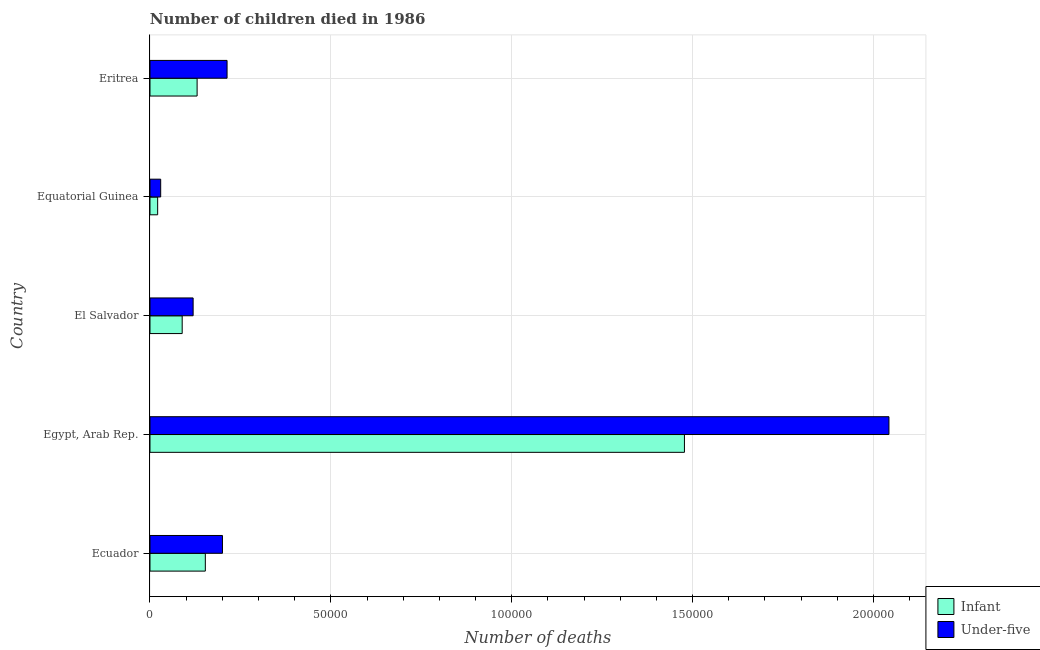Are the number of bars per tick equal to the number of legend labels?
Provide a succinct answer. Yes. Are the number of bars on each tick of the Y-axis equal?
Your answer should be very brief. Yes. How many bars are there on the 2nd tick from the top?
Give a very brief answer. 2. What is the label of the 3rd group of bars from the top?
Give a very brief answer. El Salvador. In how many cases, is the number of bars for a given country not equal to the number of legend labels?
Keep it short and to the point. 0. What is the number of under-five deaths in Ecuador?
Your answer should be very brief. 2.00e+04. Across all countries, what is the maximum number of infant deaths?
Offer a terse response. 1.48e+05. Across all countries, what is the minimum number of infant deaths?
Make the answer very short. 2121. In which country was the number of infant deaths maximum?
Offer a very short reply. Egypt, Arab Rep. In which country was the number of infant deaths minimum?
Your answer should be very brief. Equatorial Guinea. What is the total number of under-five deaths in the graph?
Ensure brevity in your answer.  2.61e+05. What is the difference between the number of infant deaths in El Salvador and that in Eritrea?
Ensure brevity in your answer.  -4123. What is the difference between the number of under-five deaths in Eritrea and the number of infant deaths in Equatorial Guinea?
Offer a very short reply. 1.92e+04. What is the average number of infant deaths per country?
Provide a succinct answer. 3.74e+04. What is the difference between the number of infant deaths and number of under-five deaths in Ecuador?
Ensure brevity in your answer.  -4734. In how many countries, is the number of infant deaths greater than 40000 ?
Offer a terse response. 1. What is the ratio of the number of infant deaths in Egypt, Arab Rep. to that in Equatorial Guinea?
Give a very brief answer. 69.66. What is the difference between the highest and the second highest number of under-five deaths?
Provide a short and direct response. 1.83e+05. What is the difference between the highest and the lowest number of under-five deaths?
Ensure brevity in your answer.  2.01e+05. Is the sum of the number of infant deaths in Equatorial Guinea and Eritrea greater than the maximum number of under-five deaths across all countries?
Give a very brief answer. No. What does the 2nd bar from the top in Ecuador represents?
Offer a very short reply. Infant. What does the 2nd bar from the bottom in Equatorial Guinea represents?
Offer a very short reply. Under-five. How many bars are there?
Give a very brief answer. 10. Are all the bars in the graph horizontal?
Keep it short and to the point. Yes. How many countries are there in the graph?
Your answer should be very brief. 5. What is the difference between two consecutive major ticks on the X-axis?
Make the answer very short. 5.00e+04. Are the values on the major ticks of X-axis written in scientific E-notation?
Ensure brevity in your answer.  No. How many legend labels are there?
Offer a terse response. 2. What is the title of the graph?
Keep it short and to the point. Number of children died in 1986. Does "Fertility rate" appear as one of the legend labels in the graph?
Ensure brevity in your answer.  No. What is the label or title of the X-axis?
Offer a very short reply. Number of deaths. What is the Number of deaths of Infant in Ecuador?
Offer a terse response. 1.53e+04. What is the Number of deaths of Under-five in Ecuador?
Your answer should be compact. 2.00e+04. What is the Number of deaths in Infant in Egypt, Arab Rep.?
Your answer should be compact. 1.48e+05. What is the Number of deaths in Under-five in Egypt, Arab Rep.?
Offer a very short reply. 2.04e+05. What is the Number of deaths in Infant in El Salvador?
Your answer should be compact. 8903. What is the Number of deaths in Under-five in El Salvador?
Keep it short and to the point. 1.19e+04. What is the Number of deaths of Infant in Equatorial Guinea?
Provide a succinct answer. 2121. What is the Number of deaths of Under-five in Equatorial Guinea?
Provide a succinct answer. 2956. What is the Number of deaths in Infant in Eritrea?
Offer a very short reply. 1.30e+04. What is the Number of deaths in Under-five in Eritrea?
Your answer should be very brief. 2.13e+04. Across all countries, what is the maximum Number of deaths in Infant?
Keep it short and to the point. 1.48e+05. Across all countries, what is the maximum Number of deaths in Under-five?
Keep it short and to the point. 2.04e+05. Across all countries, what is the minimum Number of deaths of Infant?
Your response must be concise. 2121. Across all countries, what is the minimum Number of deaths in Under-five?
Your answer should be compact. 2956. What is the total Number of deaths of Infant in the graph?
Make the answer very short. 1.87e+05. What is the total Number of deaths in Under-five in the graph?
Your answer should be compact. 2.61e+05. What is the difference between the Number of deaths in Infant in Ecuador and that in Egypt, Arab Rep.?
Your answer should be very brief. -1.32e+05. What is the difference between the Number of deaths of Under-five in Ecuador and that in Egypt, Arab Rep.?
Offer a very short reply. -1.84e+05. What is the difference between the Number of deaths in Infant in Ecuador and that in El Salvador?
Give a very brief answer. 6395. What is the difference between the Number of deaths in Under-five in Ecuador and that in El Salvador?
Your answer should be compact. 8105. What is the difference between the Number of deaths in Infant in Ecuador and that in Equatorial Guinea?
Your answer should be compact. 1.32e+04. What is the difference between the Number of deaths in Under-five in Ecuador and that in Equatorial Guinea?
Give a very brief answer. 1.71e+04. What is the difference between the Number of deaths of Infant in Ecuador and that in Eritrea?
Provide a short and direct response. 2272. What is the difference between the Number of deaths of Under-five in Ecuador and that in Eritrea?
Offer a very short reply. -1276. What is the difference between the Number of deaths of Infant in Egypt, Arab Rep. and that in El Salvador?
Your response must be concise. 1.39e+05. What is the difference between the Number of deaths of Under-five in Egypt, Arab Rep. and that in El Salvador?
Your answer should be compact. 1.92e+05. What is the difference between the Number of deaths in Infant in Egypt, Arab Rep. and that in Equatorial Guinea?
Make the answer very short. 1.46e+05. What is the difference between the Number of deaths in Under-five in Egypt, Arab Rep. and that in Equatorial Guinea?
Your response must be concise. 2.01e+05. What is the difference between the Number of deaths in Infant in Egypt, Arab Rep. and that in Eritrea?
Your answer should be very brief. 1.35e+05. What is the difference between the Number of deaths of Under-five in Egypt, Arab Rep. and that in Eritrea?
Offer a very short reply. 1.83e+05. What is the difference between the Number of deaths of Infant in El Salvador and that in Equatorial Guinea?
Your answer should be compact. 6782. What is the difference between the Number of deaths of Under-five in El Salvador and that in Equatorial Guinea?
Keep it short and to the point. 8971. What is the difference between the Number of deaths of Infant in El Salvador and that in Eritrea?
Offer a very short reply. -4123. What is the difference between the Number of deaths in Under-five in El Salvador and that in Eritrea?
Offer a terse response. -9381. What is the difference between the Number of deaths in Infant in Equatorial Guinea and that in Eritrea?
Provide a succinct answer. -1.09e+04. What is the difference between the Number of deaths in Under-five in Equatorial Guinea and that in Eritrea?
Ensure brevity in your answer.  -1.84e+04. What is the difference between the Number of deaths of Infant in Ecuador and the Number of deaths of Under-five in Egypt, Arab Rep.?
Your response must be concise. -1.89e+05. What is the difference between the Number of deaths of Infant in Ecuador and the Number of deaths of Under-five in El Salvador?
Your answer should be compact. 3371. What is the difference between the Number of deaths in Infant in Ecuador and the Number of deaths in Under-five in Equatorial Guinea?
Your response must be concise. 1.23e+04. What is the difference between the Number of deaths in Infant in Ecuador and the Number of deaths in Under-five in Eritrea?
Offer a terse response. -6010. What is the difference between the Number of deaths in Infant in Egypt, Arab Rep. and the Number of deaths in Under-five in El Salvador?
Provide a short and direct response. 1.36e+05. What is the difference between the Number of deaths in Infant in Egypt, Arab Rep. and the Number of deaths in Under-five in Equatorial Guinea?
Make the answer very short. 1.45e+05. What is the difference between the Number of deaths in Infant in Egypt, Arab Rep. and the Number of deaths in Under-five in Eritrea?
Provide a succinct answer. 1.26e+05. What is the difference between the Number of deaths in Infant in El Salvador and the Number of deaths in Under-five in Equatorial Guinea?
Give a very brief answer. 5947. What is the difference between the Number of deaths in Infant in El Salvador and the Number of deaths in Under-five in Eritrea?
Your answer should be very brief. -1.24e+04. What is the difference between the Number of deaths of Infant in Equatorial Guinea and the Number of deaths of Under-five in Eritrea?
Offer a terse response. -1.92e+04. What is the average Number of deaths in Infant per country?
Your response must be concise. 3.74e+04. What is the average Number of deaths in Under-five per country?
Ensure brevity in your answer.  5.21e+04. What is the difference between the Number of deaths in Infant and Number of deaths in Under-five in Ecuador?
Offer a terse response. -4734. What is the difference between the Number of deaths of Infant and Number of deaths of Under-five in Egypt, Arab Rep.?
Ensure brevity in your answer.  -5.65e+04. What is the difference between the Number of deaths of Infant and Number of deaths of Under-five in El Salvador?
Your answer should be very brief. -3024. What is the difference between the Number of deaths of Infant and Number of deaths of Under-five in Equatorial Guinea?
Your answer should be very brief. -835. What is the difference between the Number of deaths in Infant and Number of deaths in Under-five in Eritrea?
Ensure brevity in your answer.  -8282. What is the ratio of the Number of deaths of Infant in Ecuador to that in Egypt, Arab Rep.?
Keep it short and to the point. 0.1. What is the ratio of the Number of deaths in Under-five in Ecuador to that in Egypt, Arab Rep.?
Give a very brief answer. 0.1. What is the ratio of the Number of deaths in Infant in Ecuador to that in El Salvador?
Make the answer very short. 1.72. What is the ratio of the Number of deaths of Under-five in Ecuador to that in El Salvador?
Make the answer very short. 1.68. What is the ratio of the Number of deaths in Infant in Ecuador to that in Equatorial Guinea?
Your answer should be very brief. 7.21. What is the ratio of the Number of deaths of Under-five in Ecuador to that in Equatorial Guinea?
Give a very brief answer. 6.78. What is the ratio of the Number of deaths of Infant in Ecuador to that in Eritrea?
Your response must be concise. 1.17. What is the ratio of the Number of deaths in Under-five in Ecuador to that in Eritrea?
Ensure brevity in your answer.  0.94. What is the ratio of the Number of deaths in Infant in Egypt, Arab Rep. to that in El Salvador?
Your answer should be compact. 16.6. What is the ratio of the Number of deaths in Under-five in Egypt, Arab Rep. to that in El Salvador?
Your answer should be compact. 17.13. What is the ratio of the Number of deaths in Infant in Egypt, Arab Rep. to that in Equatorial Guinea?
Keep it short and to the point. 69.66. What is the ratio of the Number of deaths of Under-five in Egypt, Arab Rep. to that in Equatorial Guinea?
Your response must be concise. 69.11. What is the ratio of the Number of deaths in Infant in Egypt, Arab Rep. to that in Eritrea?
Give a very brief answer. 11.34. What is the ratio of the Number of deaths in Under-five in Egypt, Arab Rep. to that in Eritrea?
Provide a succinct answer. 9.59. What is the ratio of the Number of deaths in Infant in El Salvador to that in Equatorial Guinea?
Keep it short and to the point. 4.2. What is the ratio of the Number of deaths in Under-five in El Salvador to that in Equatorial Guinea?
Give a very brief answer. 4.03. What is the ratio of the Number of deaths in Infant in El Salvador to that in Eritrea?
Provide a succinct answer. 0.68. What is the ratio of the Number of deaths in Under-five in El Salvador to that in Eritrea?
Your response must be concise. 0.56. What is the ratio of the Number of deaths in Infant in Equatorial Guinea to that in Eritrea?
Provide a short and direct response. 0.16. What is the ratio of the Number of deaths in Under-five in Equatorial Guinea to that in Eritrea?
Ensure brevity in your answer.  0.14. What is the difference between the highest and the second highest Number of deaths in Infant?
Keep it short and to the point. 1.32e+05. What is the difference between the highest and the second highest Number of deaths in Under-five?
Offer a very short reply. 1.83e+05. What is the difference between the highest and the lowest Number of deaths of Infant?
Give a very brief answer. 1.46e+05. What is the difference between the highest and the lowest Number of deaths in Under-five?
Your response must be concise. 2.01e+05. 